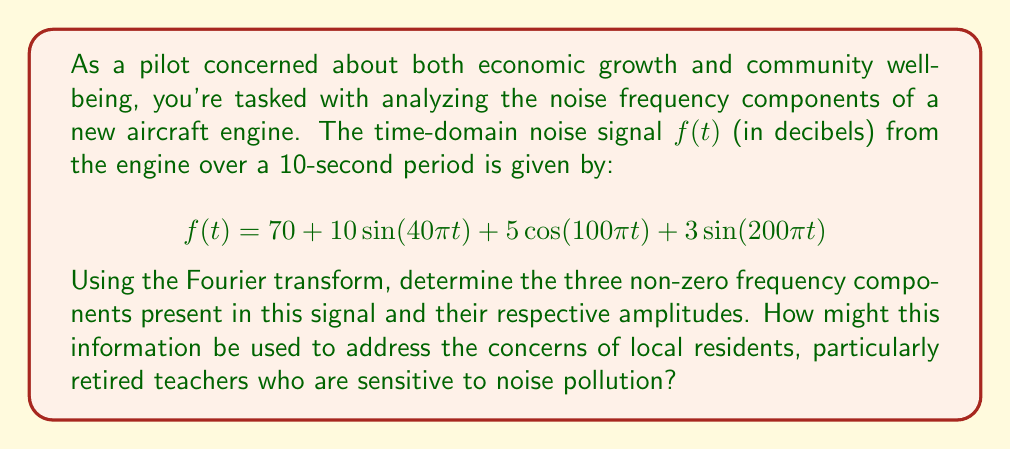Can you solve this math problem? To solve this problem, we need to analyze the given time-domain signal using the Fourier transform. The Fourier transform will help us identify the frequency components and their amplitudes.

1) First, let's identify the general form of the signal:
   $$f(t) = A_0 + A_1\sin(2\pi f_1 t) + A_2\cos(2\pi f_2 t) + A_3\sin(2\pi f_3 t)$$

2) Comparing this to our given function:
   $$f(t) = 70 + 10\sin(40\pi t) + 5\cos(100\pi t) + 3\sin(200\pi t)$$

3) We can identify:
   - $A_0 = 70$ (DC component, frequency = 0 Hz)
   - $A_1 = 10$, $2\pi f_1 = 40\pi$, so $f_1 = 20$ Hz
   - $A_2 = 5$, $2\pi f_2 = 100\pi$, so $f_2 = 50$ Hz
   - $A_3 = 3$, $2\pi f_3 = 200\pi$, so $f_3 = 100$ Hz

4) The Fourier transform will show these as peaks at the corresponding frequencies.

5) The amplitudes in the frequency domain will be:
   - At 0 Hz: 70 (DC component)
   - At 20 Hz: 10
   - At 50 Hz: 5
   - At 100 Hz: 3

This information can be used to address residents' concerns by:
1) Identifying which frequencies contribute most to the noise.
2) Developing noise reduction strategies targeting these specific frequencies.
3) Comparing these frequencies to human hearing sensitivity, especially for older individuals who may have age-related hearing loss.
4) Designing flight paths and operational procedures to minimize the impact of the most problematic frequencies on residential areas.
Answer: The three non-zero frequency components and their amplitudes are:
1) 20 Hz with amplitude 10
2) 50 Hz with amplitude 5
3) 100 Hz with amplitude 3 